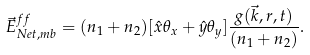<formula> <loc_0><loc_0><loc_500><loc_500>\vec { E } ^ { f f } _ { N e t , m b } = ( n _ { 1 } + n _ { 2 } ) [ \hat { x } \theta _ { x } + \hat { y } \theta _ { y } ] \frac { g ( \vec { k } , r , t ) } { ( n _ { 1 } + n _ { 2 } ) } .</formula> 